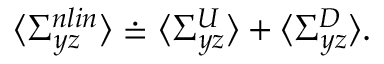Convert formula to latex. <formula><loc_0><loc_0><loc_500><loc_500>\langle \Sigma _ { y z } ^ { n l i n } \rangle \doteq \langle \Sigma _ { y z } ^ { U } \rangle + \langle \Sigma _ { y z } ^ { D } \rangle .</formula> 